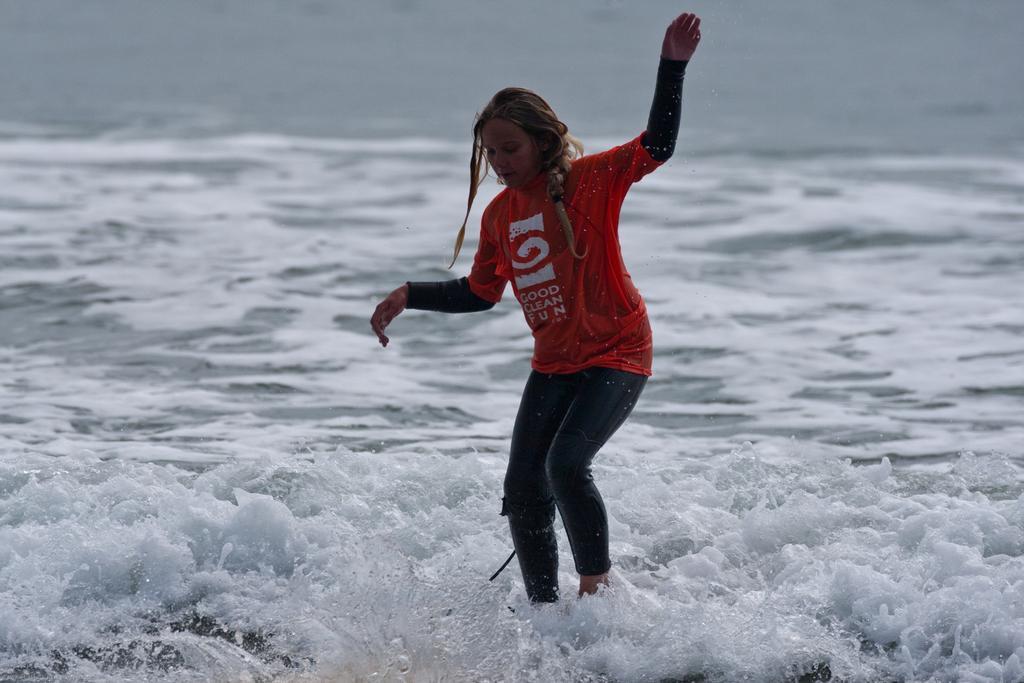In one or two sentences, can you explain what this image depicts? In this picture we can see the water. This picture is mainly highlighted with a woman wearing a red t-shirt. 